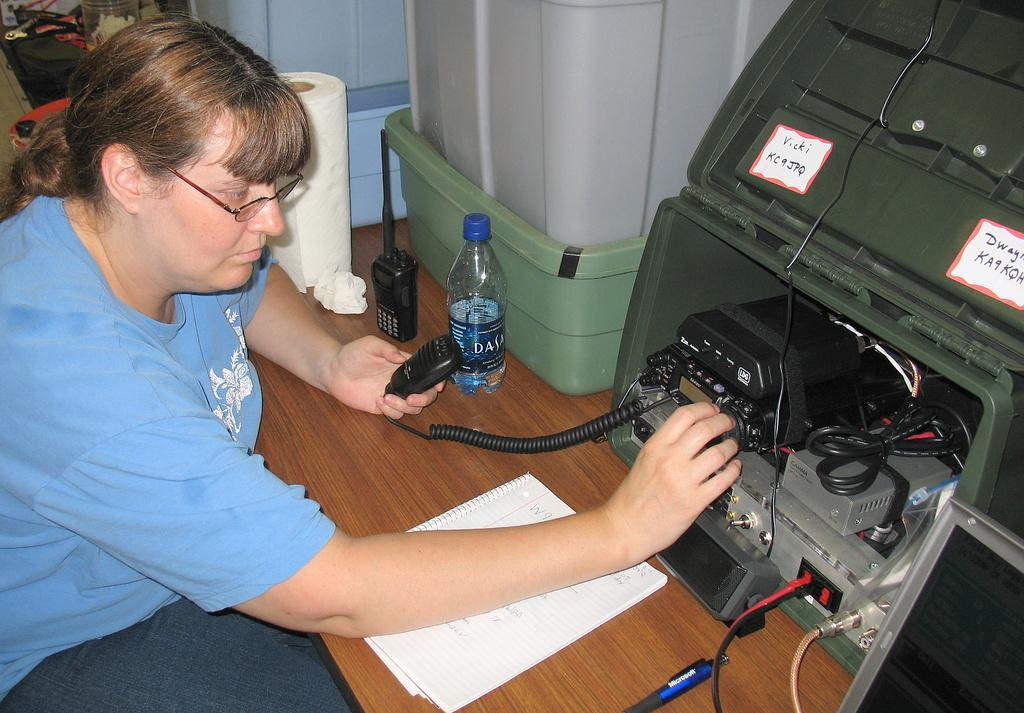Provide a one-sentence caption for the provided image. the lady has a bottle of Dasani water on her desk. 